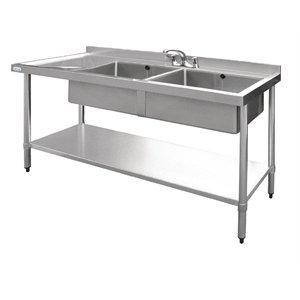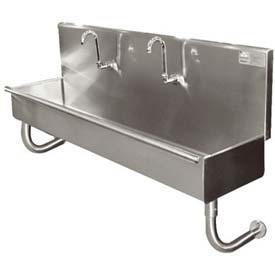The first image is the image on the left, the second image is the image on the right. For the images shown, is this caption "Two silvery metal prep sinks stand on legs, and each has two or more sink bowls." true? Answer yes or no. No. 